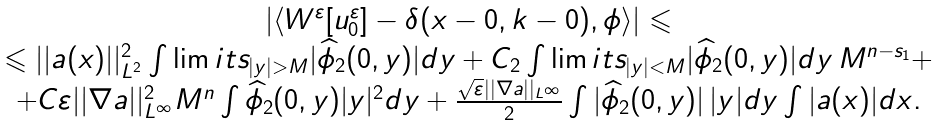<formula> <loc_0><loc_0><loc_500><loc_500>\begin{array} { c } \left | { \langle W ^ { \varepsilon } [ u ^ { \varepsilon } _ { 0 } ] - \delta ( x - 0 , k - 0 ) , \phi \rangle } \right | \leqslant \\ \leqslant | | a ( x ) | | _ { L ^ { 2 } } ^ { 2 } \int \lim i t s _ { | y | > M } { | \widehat { \phi } _ { 2 } ( 0 , y ) | d y } + C _ { 2 } \int \lim i t s _ { | y | < M } { | \widehat { \phi } _ { 2 } ( 0 , y ) | d y } \, M ^ { n - s _ { 1 } } + \\ + C \varepsilon | | \nabla a | | ^ { 2 } _ { L ^ { \infty } } M ^ { n } \int { \widehat { \phi } _ { 2 } ( 0 , y ) | y | ^ { 2 } d y } + \frac { \sqrt { \varepsilon } | | \nabla a | | _ { L ^ { \infty } } } { 2 } \int { | \widehat { \phi } _ { 2 } ( 0 , y ) | \, | y | d y } \int { | a ( x ) | d x } . \end{array}</formula> 